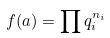Convert formula to latex. <formula><loc_0><loc_0><loc_500><loc_500>f ( a ) = \prod q _ { i } ^ { n _ { i } }</formula> 